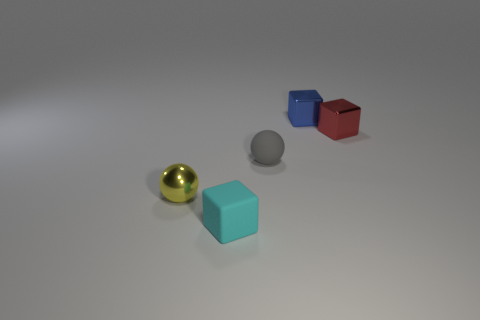The metallic object left of the tiny blue object has what shape?
Your answer should be very brief. Sphere. What number of things are left of the sphere that is in front of the tiny gray sphere that is on the right side of the tiny cyan matte block?
Offer a very short reply. 0. How many other objects are there of the same shape as the yellow metallic object?
Your response must be concise. 1. What number of other things are there of the same material as the tiny red object
Your answer should be compact. 2. What is the material of the tiny ball left of the block in front of the rubber sphere right of the small cyan thing?
Your answer should be compact. Metal. Are the yellow object and the gray sphere made of the same material?
Your answer should be compact. No. What number of balls are brown rubber objects or small metallic things?
Give a very brief answer. 1. There is a metal block that is behind the red cube; what is its color?
Keep it short and to the point. Blue. How many matte things are tiny cyan blocks or large green cubes?
Your answer should be very brief. 1. What is the material of the ball that is left of the small thing that is in front of the yellow shiny sphere?
Provide a succinct answer. Metal. 